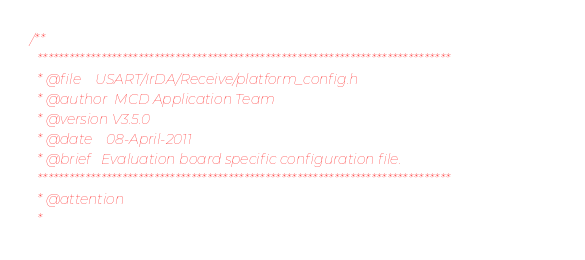Convert code to text. <code><loc_0><loc_0><loc_500><loc_500><_C_>/**
  ******************************************************************************
  * @file    USART/IrDA/Receive/platform_config.h 
  * @author  MCD Application Team
  * @version V3.5.0
  * @date    08-April-2011
  * @brief   Evaluation board specific configuration file.
  ******************************************************************************
  * @attention
  *</code> 